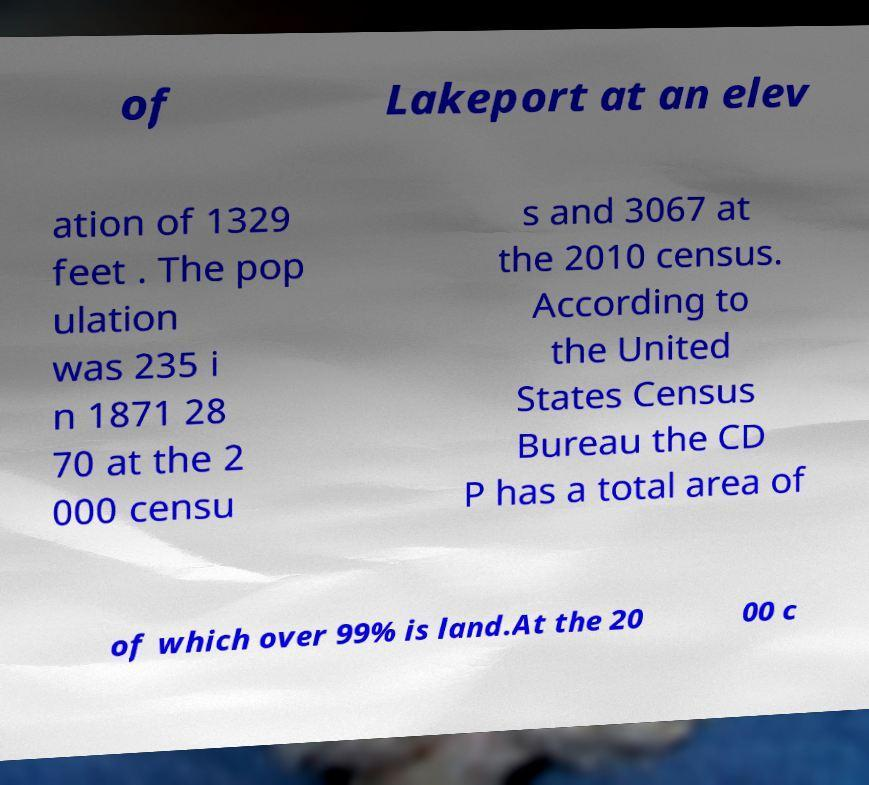Please read and relay the text visible in this image. What does it say? of Lakeport at an elev ation of 1329 feet . The pop ulation was 235 i n 1871 28 70 at the 2 000 censu s and 3067 at the 2010 census. According to the United States Census Bureau the CD P has a total area of of which over 99% is land.At the 20 00 c 